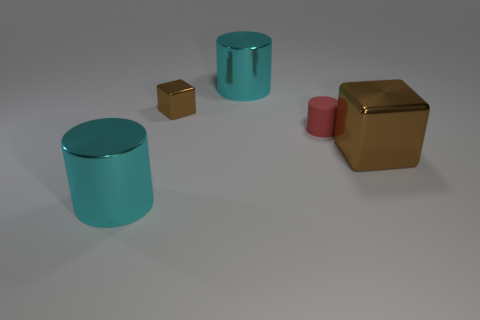Can you describe the ambiance or mood of the image based on the colors and lighting? The image exudes a serene and minimalist ambiance, achieved through soft lighting and the muted, pastel-like turquoise color of the cylindrical objects. This tranquility is contrasted by the golden cubes, which add a touch of sophisticated warmth. 